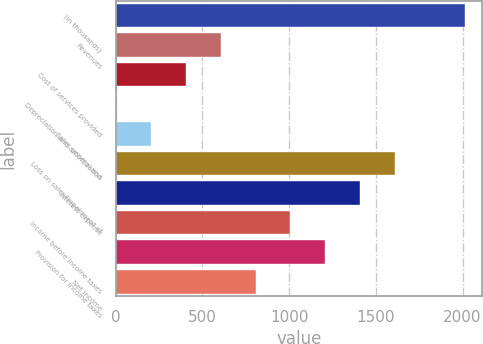<chart> <loc_0><loc_0><loc_500><loc_500><bar_chart><fcel>(in thousands)<fcel>Revenues<fcel>Cost of services provided<fcel>Depreciation and amortization<fcel>Sales general and<fcel>Loss on sales/impairment of<fcel>Interest expense<fcel>Income before income taxes<fcel>Provision for income taxes<fcel>Net income<nl><fcel>2011<fcel>605.4<fcel>404.6<fcel>3<fcel>203.8<fcel>1609.4<fcel>1408.6<fcel>1007<fcel>1207.8<fcel>806.2<nl></chart> 